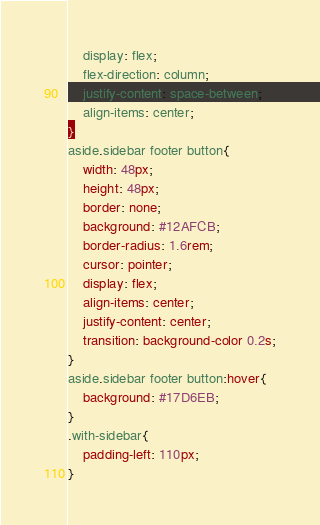<code> <loc_0><loc_0><loc_500><loc_500><_CSS_>    display: flex;
    flex-direction: column;
    justify-content: space-between;
    align-items: center;
}
aside.sidebar footer button{
    width: 48px;
    height: 48px;
    border: none;
    background: #12AFCB;
    border-radius: 1.6rem;
    cursor: pointer;
    display: flex;
    align-items: center;
    justify-content: center;
    transition: background-color 0.2s;
}
aside.sidebar footer button:hover{
    background: #17D6EB;
}
.with-sidebar{
    padding-left: 110px;
}
</code> 